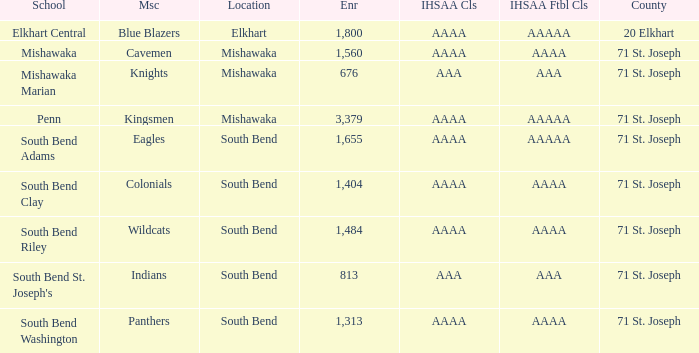I'm looking to parse the entire table for insights. Could you assist me with that? {'header': ['School', 'Msc', 'Location', 'Enr', 'IHSAA Cls', 'IHSAA Ftbl Cls', 'County'], 'rows': [['Elkhart Central', 'Blue Blazers', 'Elkhart', '1,800', 'AAAA', 'AAAAA', '20 Elkhart'], ['Mishawaka', 'Cavemen', 'Mishawaka', '1,560', 'AAAA', 'AAAA', '71 St. Joseph'], ['Mishawaka Marian', 'Knights', 'Mishawaka', '676', 'AAA', 'AAA', '71 St. Joseph'], ['Penn', 'Kingsmen', 'Mishawaka', '3,379', 'AAAA', 'AAAAA', '71 St. Joseph'], ['South Bend Adams', 'Eagles', 'South Bend', '1,655', 'AAAA', 'AAAAA', '71 St. Joseph'], ['South Bend Clay', 'Colonials', 'South Bend', '1,404', 'AAAA', 'AAAA', '71 St. Joseph'], ['South Bend Riley', 'Wildcats', 'South Bend', '1,484', 'AAAA', 'AAAA', '71 St. Joseph'], ["South Bend St. Joseph's", 'Indians', 'South Bend', '813', 'AAA', 'AAA', '71 St. Joseph'], ['South Bend Washington', 'Panthers', 'South Bend', '1,313', 'AAAA', 'AAAA', '71 St. Joseph']]} What IHSAA Football Class has 20 elkhart as the county? AAAAA. 